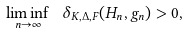Convert formula to latex. <formula><loc_0><loc_0><loc_500><loc_500>\liminf _ { n \rightarrow \infty } \ \delta _ { K , \Delta , F } ( { H } _ { n } , g _ { n } ) > 0 ,</formula> 